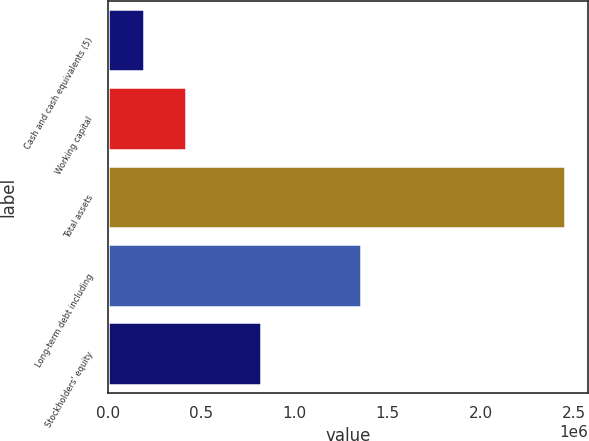Convert chart to OTSL. <chart><loc_0><loc_0><loc_500><loc_500><bar_chart><fcel>Cash and cash equivalents (5)<fcel>Working capital<fcel>Total assets<fcel>Long-term debt including<fcel>Stockholders' equity<nl><fcel>190167<fcel>416594<fcel>2.45444e+06<fcel>1.35676e+06<fcel>819162<nl></chart> 